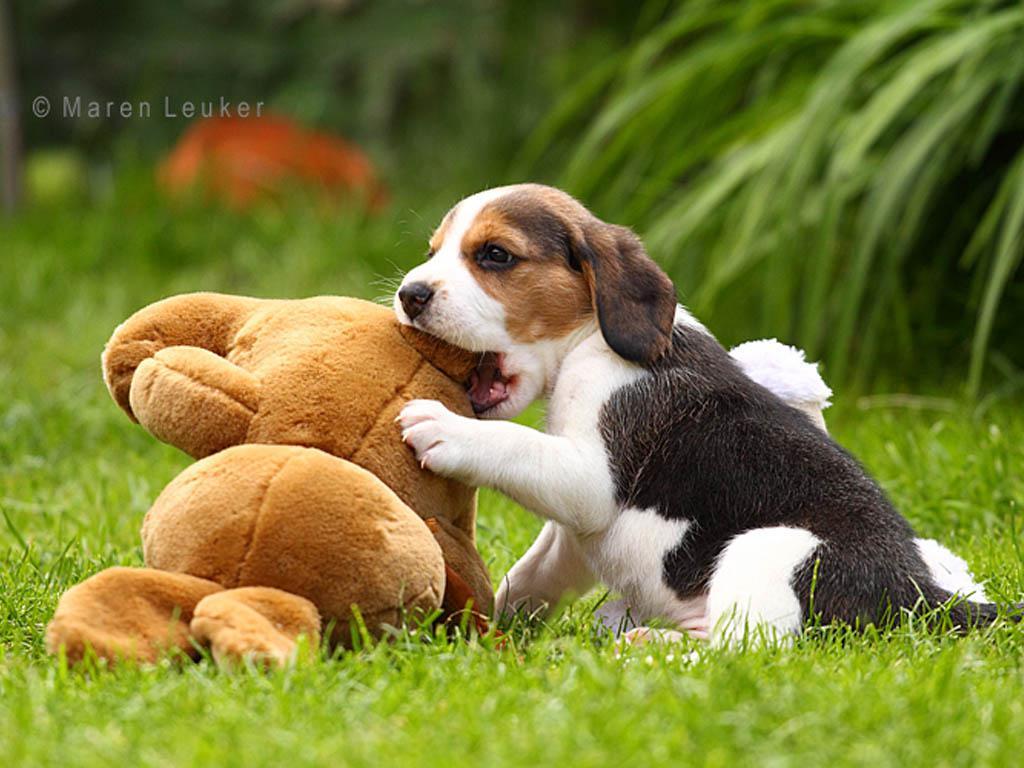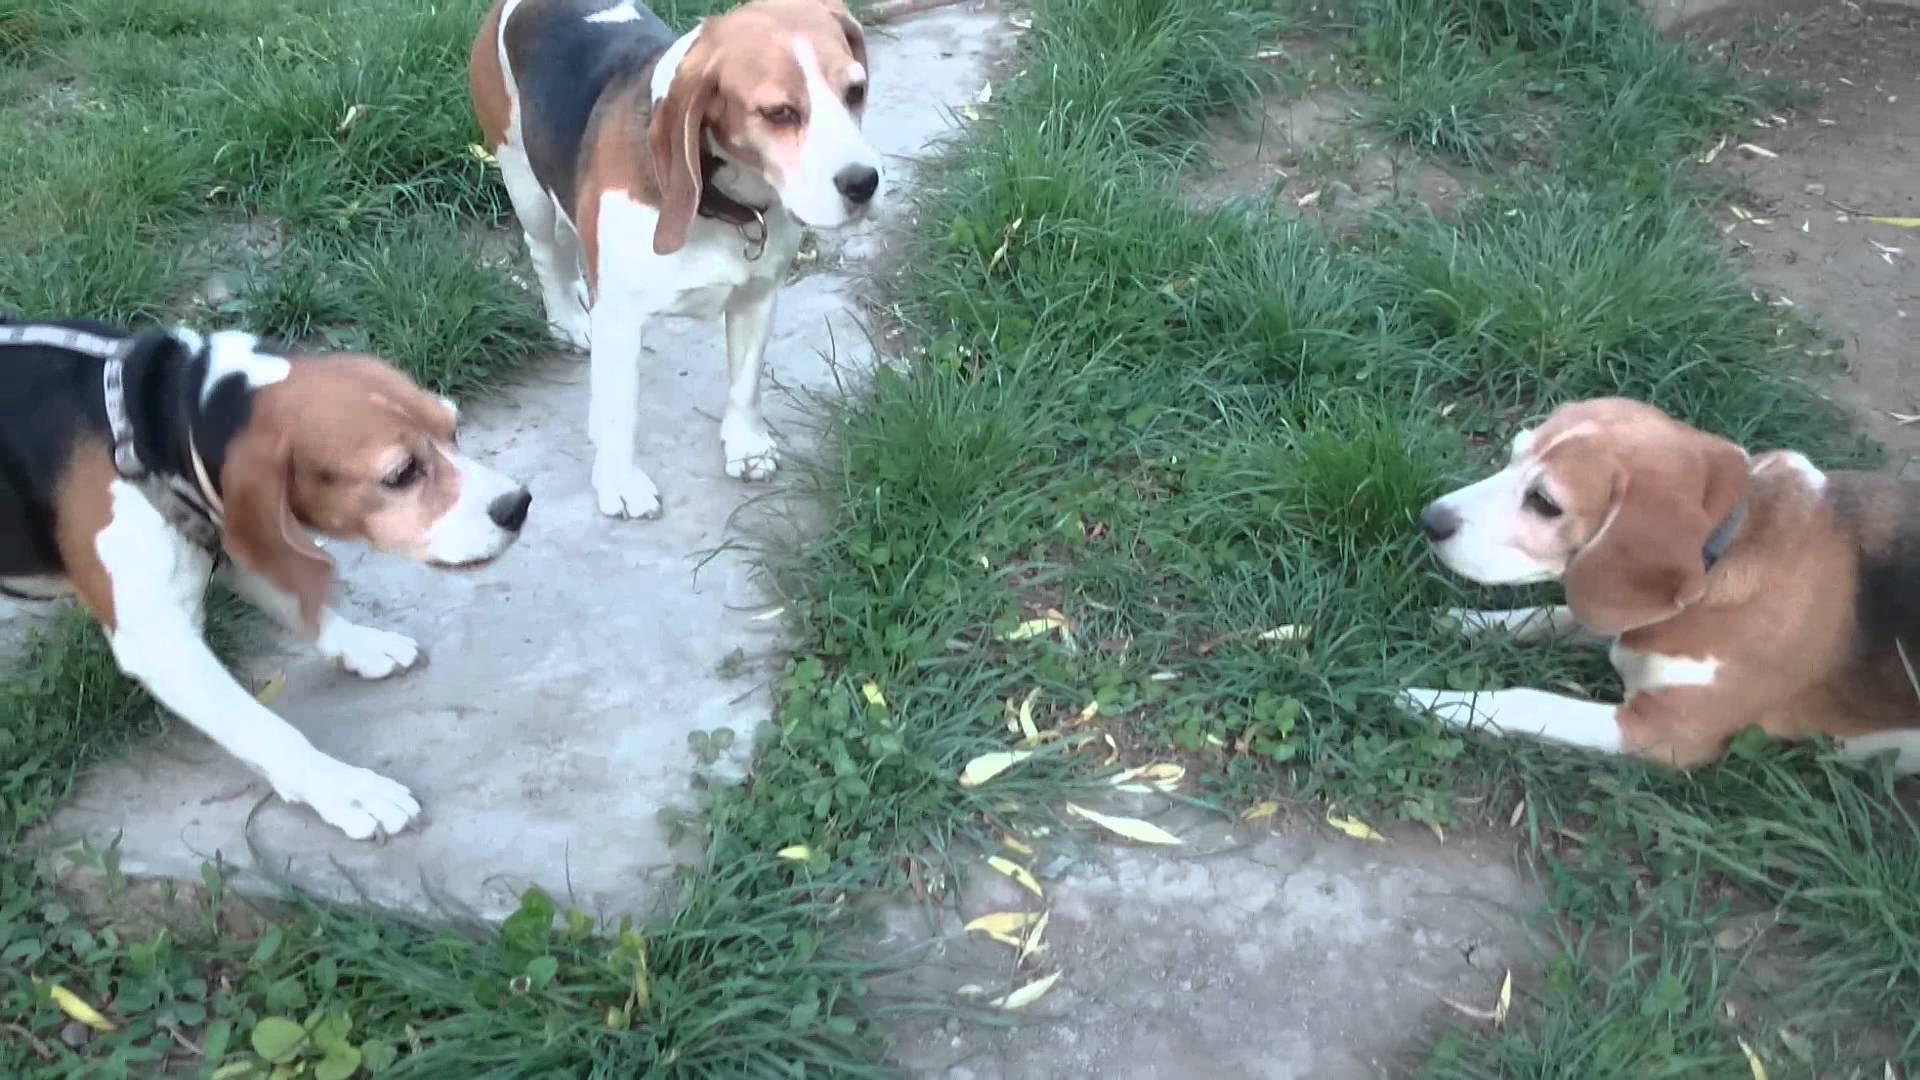The first image is the image on the left, the second image is the image on the right. For the images shown, is this caption "An image contains exactly one dog, a beagle puppy that is sitting on green grass." true? Answer yes or no. Yes. The first image is the image on the left, the second image is the image on the right. For the images displayed, is the sentence "The right image contains no more than three dogs." factually correct? Answer yes or no. Yes. 